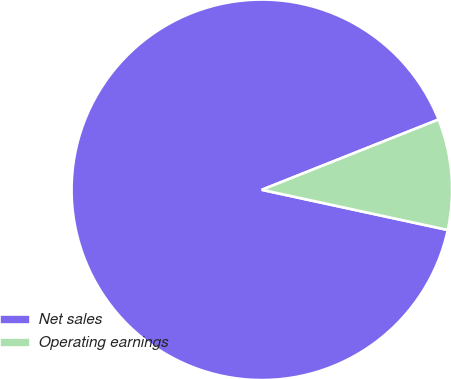Convert chart. <chart><loc_0><loc_0><loc_500><loc_500><pie_chart><fcel>Net sales<fcel>Operating earnings<nl><fcel>90.59%<fcel>9.41%<nl></chart> 